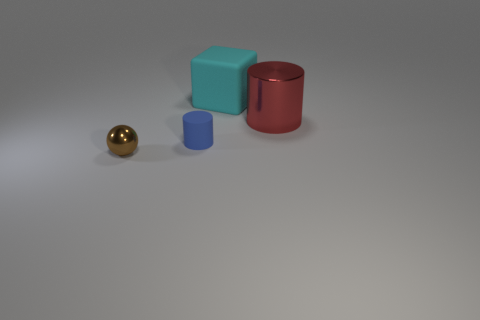Add 1 cubes. How many objects exist? 5 Subtract all red cylinders. How many cylinders are left? 1 Subtract all balls. How many objects are left? 3 Subtract 1 cylinders. How many cylinders are left? 1 Add 1 red shiny cylinders. How many red shiny cylinders exist? 2 Subtract 0 purple spheres. How many objects are left? 4 Subtract all gray cylinders. Subtract all brown balls. How many cylinders are left? 2 Subtract all small purple matte cylinders. Subtract all brown things. How many objects are left? 3 Add 1 red cylinders. How many red cylinders are left? 2 